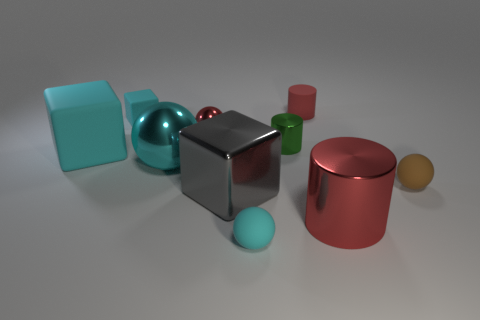Subtract all cubes. How many objects are left? 7 Add 5 big yellow matte balls. How many big yellow matte balls exist? 5 Subtract 0 yellow cylinders. How many objects are left? 10 Subtract all small gray rubber cylinders. Subtract all small red cylinders. How many objects are left? 9 Add 3 brown things. How many brown things are left? 4 